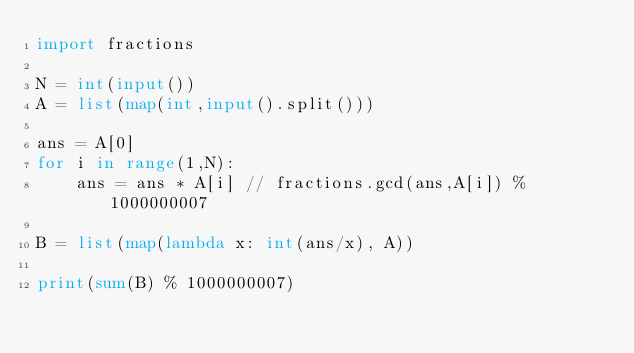<code> <loc_0><loc_0><loc_500><loc_500><_Python_>import fractions

N = int(input())
A = list(map(int,input().split()))

ans = A[0]
for i in range(1,N):
    ans = ans * A[i] // fractions.gcd(ans,A[i]) % 1000000007

B = list(map(lambda x: int(ans/x), A))

print(sum(B) % 1000000007)</code> 